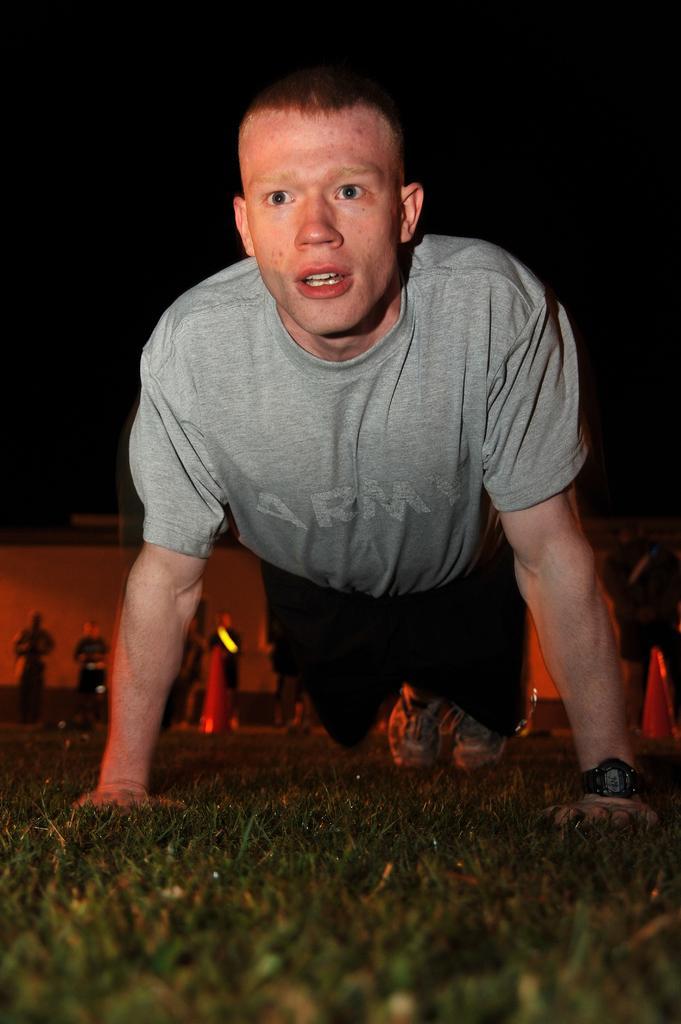How would you summarize this image in a sentence or two? In the image there is a man in grey t-shirt doing push ups on the grassland and in the back there are few persons standing. 